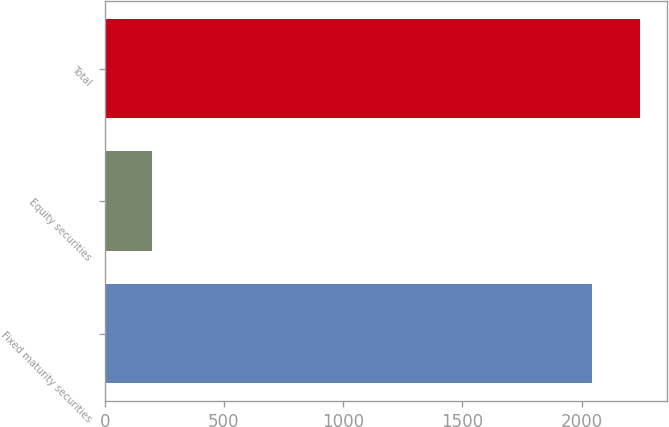Convert chart. <chart><loc_0><loc_0><loc_500><loc_500><bar_chart><fcel>Fixed maturity securities<fcel>Equity securities<fcel>Total<nl><fcel>2042<fcel>199<fcel>2246.2<nl></chart> 